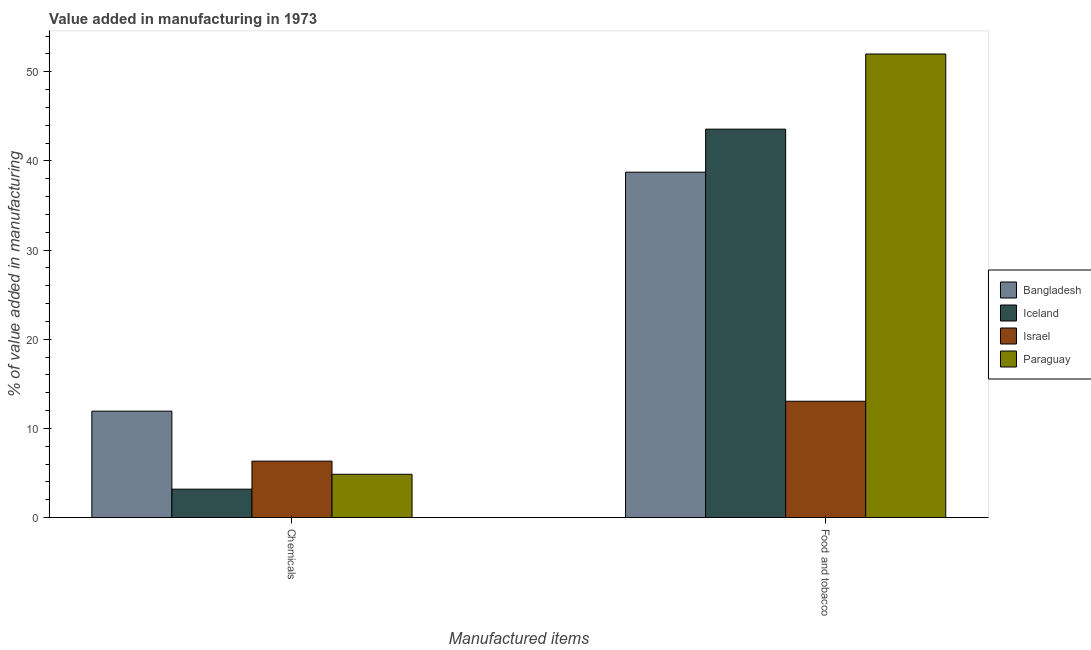What is the label of the 1st group of bars from the left?
Offer a very short reply. Chemicals. What is the value added by  manufacturing chemicals in Paraguay?
Ensure brevity in your answer.  4.85. Across all countries, what is the maximum value added by  manufacturing chemicals?
Your response must be concise. 11.93. Across all countries, what is the minimum value added by  manufacturing chemicals?
Provide a short and direct response. 3.19. In which country was the value added by  manufacturing chemicals maximum?
Provide a succinct answer. Bangladesh. What is the total value added by manufacturing food and tobacco in the graph?
Your answer should be very brief. 147.34. What is the difference between the value added by manufacturing food and tobacco in Iceland and that in Paraguay?
Offer a very short reply. -8.43. What is the difference between the value added by  manufacturing chemicals in Israel and the value added by manufacturing food and tobacco in Paraguay?
Your answer should be very brief. -45.66. What is the average value added by manufacturing food and tobacco per country?
Offer a terse response. 36.83. What is the difference between the value added by manufacturing food and tobacco and value added by  manufacturing chemicals in Israel?
Give a very brief answer. 6.72. In how many countries, is the value added by manufacturing food and tobacco greater than 38 %?
Your answer should be very brief. 3. What is the ratio of the value added by manufacturing food and tobacco in Iceland to that in Bangladesh?
Ensure brevity in your answer.  1.12. Is the value added by  manufacturing chemicals in Paraguay less than that in Bangladesh?
Give a very brief answer. Yes. In how many countries, is the value added by  manufacturing chemicals greater than the average value added by  manufacturing chemicals taken over all countries?
Provide a short and direct response. 1. How many bars are there?
Provide a succinct answer. 8. Are all the bars in the graph horizontal?
Give a very brief answer. No. How many countries are there in the graph?
Your answer should be compact. 4. What is the difference between two consecutive major ticks on the Y-axis?
Provide a succinct answer. 10. Are the values on the major ticks of Y-axis written in scientific E-notation?
Make the answer very short. No. Does the graph contain grids?
Your answer should be compact. No. Where does the legend appear in the graph?
Keep it short and to the point. Center right. How many legend labels are there?
Your response must be concise. 4. How are the legend labels stacked?
Your response must be concise. Vertical. What is the title of the graph?
Make the answer very short. Value added in manufacturing in 1973. Does "Serbia" appear as one of the legend labels in the graph?
Offer a terse response. No. What is the label or title of the X-axis?
Your answer should be very brief. Manufactured items. What is the label or title of the Y-axis?
Ensure brevity in your answer.  % of value added in manufacturing. What is the % of value added in manufacturing in Bangladesh in Chemicals?
Your answer should be very brief. 11.93. What is the % of value added in manufacturing in Iceland in Chemicals?
Offer a very short reply. 3.19. What is the % of value added in manufacturing of Israel in Chemicals?
Offer a terse response. 6.33. What is the % of value added in manufacturing of Paraguay in Chemicals?
Your answer should be compact. 4.85. What is the % of value added in manufacturing in Bangladesh in Food and tobacco?
Give a very brief answer. 38.74. What is the % of value added in manufacturing of Iceland in Food and tobacco?
Make the answer very short. 43.56. What is the % of value added in manufacturing in Israel in Food and tobacco?
Keep it short and to the point. 13.05. What is the % of value added in manufacturing of Paraguay in Food and tobacco?
Offer a terse response. 51.99. Across all Manufactured items, what is the maximum % of value added in manufacturing in Bangladesh?
Offer a very short reply. 38.74. Across all Manufactured items, what is the maximum % of value added in manufacturing of Iceland?
Your answer should be compact. 43.56. Across all Manufactured items, what is the maximum % of value added in manufacturing in Israel?
Your response must be concise. 13.05. Across all Manufactured items, what is the maximum % of value added in manufacturing in Paraguay?
Provide a succinct answer. 51.99. Across all Manufactured items, what is the minimum % of value added in manufacturing of Bangladesh?
Provide a succinct answer. 11.93. Across all Manufactured items, what is the minimum % of value added in manufacturing in Iceland?
Keep it short and to the point. 3.19. Across all Manufactured items, what is the minimum % of value added in manufacturing of Israel?
Make the answer very short. 6.33. Across all Manufactured items, what is the minimum % of value added in manufacturing in Paraguay?
Your answer should be very brief. 4.85. What is the total % of value added in manufacturing of Bangladesh in the graph?
Provide a short and direct response. 50.67. What is the total % of value added in manufacturing of Iceland in the graph?
Give a very brief answer. 46.75. What is the total % of value added in manufacturing of Israel in the graph?
Your response must be concise. 19.37. What is the total % of value added in manufacturing in Paraguay in the graph?
Offer a very short reply. 56.85. What is the difference between the % of value added in manufacturing of Bangladesh in Chemicals and that in Food and tobacco?
Keep it short and to the point. -26.8. What is the difference between the % of value added in manufacturing of Iceland in Chemicals and that in Food and tobacco?
Make the answer very short. -40.38. What is the difference between the % of value added in manufacturing of Israel in Chemicals and that in Food and tobacco?
Your answer should be compact. -6.72. What is the difference between the % of value added in manufacturing of Paraguay in Chemicals and that in Food and tobacco?
Your response must be concise. -47.14. What is the difference between the % of value added in manufacturing of Bangladesh in Chemicals and the % of value added in manufacturing of Iceland in Food and tobacco?
Make the answer very short. -31.63. What is the difference between the % of value added in manufacturing of Bangladesh in Chemicals and the % of value added in manufacturing of Israel in Food and tobacco?
Keep it short and to the point. -1.11. What is the difference between the % of value added in manufacturing in Bangladesh in Chemicals and the % of value added in manufacturing in Paraguay in Food and tobacco?
Keep it short and to the point. -40.06. What is the difference between the % of value added in manufacturing in Iceland in Chemicals and the % of value added in manufacturing in Israel in Food and tobacco?
Your answer should be very brief. -9.86. What is the difference between the % of value added in manufacturing of Iceland in Chemicals and the % of value added in manufacturing of Paraguay in Food and tobacco?
Your response must be concise. -48.81. What is the difference between the % of value added in manufacturing of Israel in Chemicals and the % of value added in manufacturing of Paraguay in Food and tobacco?
Offer a terse response. -45.66. What is the average % of value added in manufacturing of Bangladesh per Manufactured items?
Keep it short and to the point. 25.33. What is the average % of value added in manufacturing in Iceland per Manufactured items?
Provide a succinct answer. 23.38. What is the average % of value added in manufacturing of Israel per Manufactured items?
Your response must be concise. 9.69. What is the average % of value added in manufacturing in Paraguay per Manufactured items?
Ensure brevity in your answer.  28.42. What is the difference between the % of value added in manufacturing in Bangladesh and % of value added in manufacturing in Iceland in Chemicals?
Provide a succinct answer. 8.75. What is the difference between the % of value added in manufacturing in Bangladesh and % of value added in manufacturing in Israel in Chemicals?
Provide a succinct answer. 5.61. What is the difference between the % of value added in manufacturing of Bangladesh and % of value added in manufacturing of Paraguay in Chemicals?
Ensure brevity in your answer.  7.08. What is the difference between the % of value added in manufacturing in Iceland and % of value added in manufacturing in Israel in Chemicals?
Offer a terse response. -3.14. What is the difference between the % of value added in manufacturing of Iceland and % of value added in manufacturing of Paraguay in Chemicals?
Offer a terse response. -1.67. What is the difference between the % of value added in manufacturing in Israel and % of value added in manufacturing in Paraguay in Chemicals?
Your answer should be compact. 1.47. What is the difference between the % of value added in manufacturing in Bangladesh and % of value added in manufacturing in Iceland in Food and tobacco?
Offer a terse response. -4.83. What is the difference between the % of value added in manufacturing in Bangladesh and % of value added in manufacturing in Israel in Food and tobacco?
Your answer should be compact. 25.69. What is the difference between the % of value added in manufacturing in Bangladesh and % of value added in manufacturing in Paraguay in Food and tobacco?
Ensure brevity in your answer.  -13.26. What is the difference between the % of value added in manufacturing of Iceland and % of value added in manufacturing of Israel in Food and tobacco?
Your answer should be very brief. 30.52. What is the difference between the % of value added in manufacturing in Iceland and % of value added in manufacturing in Paraguay in Food and tobacco?
Your answer should be compact. -8.43. What is the difference between the % of value added in manufacturing of Israel and % of value added in manufacturing of Paraguay in Food and tobacco?
Ensure brevity in your answer.  -38.95. What is the ratio of the % of value added in manufacturing of Bangladesh in Chemicals to that in Food and tobacco?
Ensure brevity in your answer.  0.31. What is the ratio of the % of value added in manufacturing of Iceland in Chemicals to that in Food and tobacco?
Your response must be concise. 0.07. What is the ratio of the % of value added in manufacturing in Israel in Chemicals to that in Food and tobacco?
Keep it short and to the point. 0.49. What is the ratio of the % of value added in manufacturing of Paraguay in Chemicals to that in Food and tobacco?
Ensure brevity in your answer.  0.09. What is the difference between the highest and the second highest % of value added in manufacturing of Bangladesh?
Offer a very short reply. 26.8. What is the difference between the highest and the second highest % of value added in manufacturing in Iceland?
Your response must be concise. 40.38. What is the difference between the highest and the second highest % of value added in manufacturing of Israel?
Your answer should be very brief. 6.72. What is the difference between the highest and the second highest % of value added in manufacturing of Paraguay?
Keep it short and to the point. 47.14. What is the difference between the highest and the lowest % of value added in manufacturing in Bangladesh?
Your response must be concise. 26.8. What is the difference between the highest and the lowest % of value added in manufacturing of Iceland?
Ensure brevity in your answer.  40.38. What is the difference between the highest and the lowest % of value added in manufacturing in Israel?
Provide a succinct answer. 6.72. What is the difference between the highest and the lowest % of value added in manufacturing of Paraguay?
Provide a short and direct response. 47.14. 